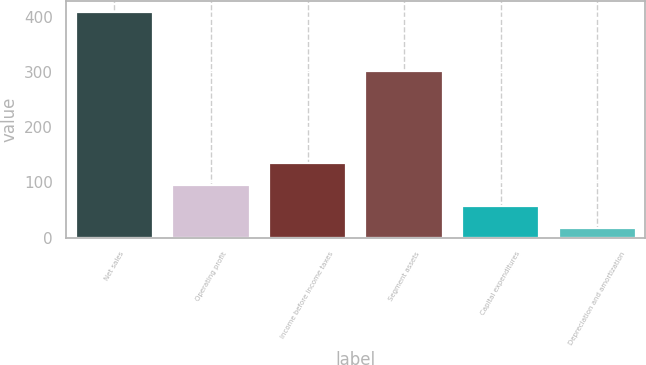Convert chart to OTSL. <chart><loc_0><loc_0><loc_500><loc_500><bar_chart><fcel>Net sales<fcel>Operating profit<fcel>Income before income taxes<fcel>Segment assets<fcel>Capital expenditures<fcel>Depreciation and amortization<nl><fcel>409.1<fcel>95.58<fcel>134.77<fcel>301.4<fcel>56.39<fcel>17.2<nl></chart> 